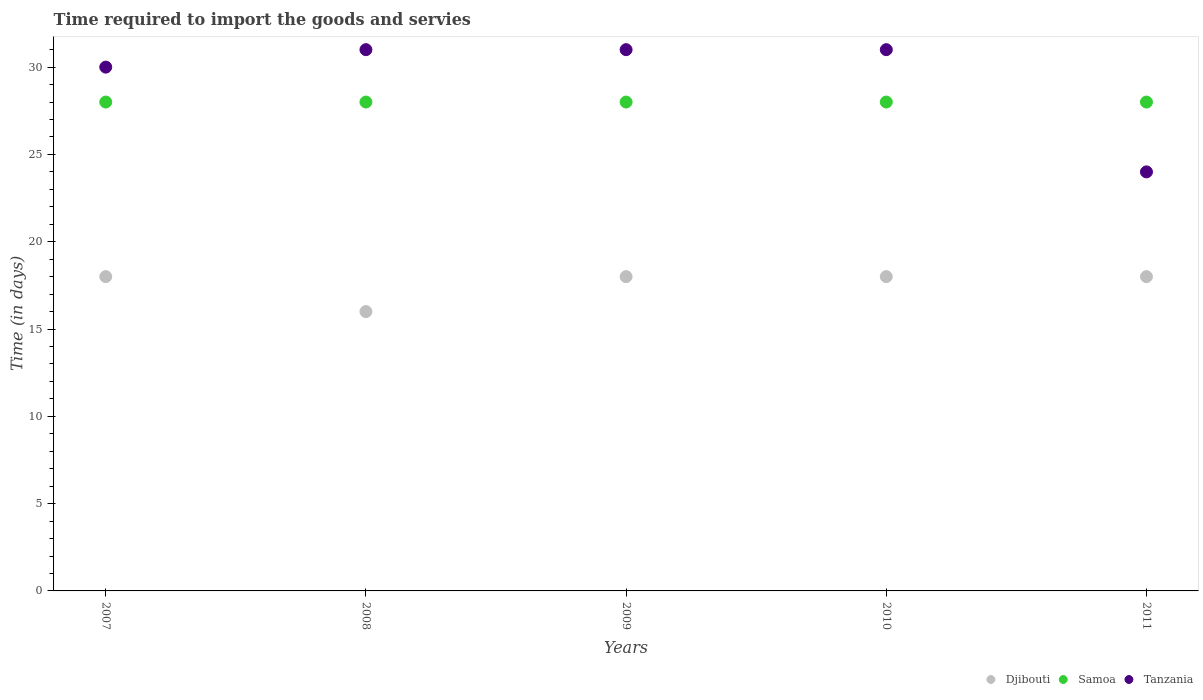What is the number of days required to import the goods and services in Tanzania in 2011?
Your answer should be very brief. 24. Across all years, what is the maximum number of days required to import the goods and services in Samoa?
Give a very brief answer. 28. Across all years, what is the minimum number of days required to import the goods and services in Djibouti?
Make the answer very short. 16. In which year was the number of days required to import the goods and services in Samoa maximum?
Provide a succinct answer. 2007. What is the total number of days required to import the goods and services in Samoa in the graph?
Ensure brevity in your answer.  140. What is the difference between the number of days required to import the goods and services in Djibouti in 2009 and that in 2011?
Make the answer very short. 0. What is the difference between the number of days required to import the goods and services in Djibouti in 2007 and the number of days required to import the goods and services in Samoa in 2010?
Make the answer very short. -10. What is the average number of days required to import the goods and services in Tanzania per year?
Give a very brief answer. 29.4. In the year 2010, what is the difference between the number of days required to import the goods and services in Samoa and number of days required to import the goods and services in Tanzania?
Keep it short and to the point. -3. In how many years, is the number of days required to import the goods and services in Samoa greater than 8 days?
Your answer should be compact. 5. Is the difference between the number of days required to import the goods and services in Samoa in 2010 and 2011 greater than the difference between the number of days required to import the goods and services in Tanzania in 2010 and 2011?
Offer a terse response. No. What is the difference between the highest and the lowest number of days required to import the goods and services in Tanzania?
Make the answer very short. 7. Is the number of days required to import the goods and services in Tanzania strictly greater than the number of days required to import the goods and services in Samoa over the years?
Your response must be concise. No. How many dotlines are there?
Keep it short and to the point. 3. Does the graph contain any zero values?
Your response must be concise. No. Does the graph contain grids?
Your answer should be compact. No. How many legend labels are there?
Your answer should be compact. 3. How are the legend labels stacked?
Your answer should be very brief. Horizontal. What is the title of the graph?
Keep it short and to the point. Time required to import the goods and servies. What is the label or title of the X-axis?
Your response must be concise. Years. What is the label or title of the Y-axis?
Keep it short and to the point. Time (in days). What is the Time (in days) of Djibouti in 2007?
Your answer should be compact. 18. What is the Time (in days) in Djibouti in 2008?
Your answer should be very brief. 16. What is the Time (in days) of Tanzania in 2008?
Provide a succinct answer. 31. What is the Time (in days) of Djibouti in 2009?
Your answer should be compact. 18. What is the Time (in days) in Samoa in 2009?
Ensure brevity in your answer.  28. What is the Time (in days) in Tanzania in 2009?
Provide a short and direct response. 31. What is the Time (in days) in Djibouti in 2010?
Provide a short and direct response. 18. What is the Time (in days) in Tanzania in 2010?
Provide a short and direct response. 31. What is the Time (in days) in Djibouti in 2011?
Provide a short and direct response. 18. What is the Time (in days) of Samoa in 2011?
Ensure brevity in your answer.  28. What is the Time (in days) in Tanzania in 2011?
Provide a succinct answer. 24. Across all years, what is the maximum Time (in days) in Tanzania?
Provide a short and direct response. 31. What is the total Time (in days) in Samoa in the graph?
Make the answer very short. 140. What is the total Time (in days) in Tanzania in the graph?
Give a very brief answer. 147. What is the difference between the Time (in days) of Tanzania in 2007 and that in 2008?
Give a very brief answer. -1. What is the difference between the Time (in days) in Tanzania in 2007 and that in 2009?
Your answer should be compact. -1. What is the difference between the Time (in days) of Tanzania in 2007 and that in 2010?
Ensure brevity in your answer.  -1. What is the difference between the Time (in days) in Djibouti in 2007 and that in 2011?
Your answer should be compact. 0. What is the difference between the Time (in days) of Samoa in 2007 and that in 2011?
Offer a terse response. 0. What is the difference between the Time (in days) of Tanzania in 2007 and that in 2011?
Ensure brevity in your answer.  6. What is the difference between the Time (in days) in Samoa in 2008 and that in 2009?
Your answer should be compact. 0. What is the difference between the Time (in days) in Samoa in 2008 and that in 2010?
Offer a terse response. 0. What is the difference between the Time (in days) of Djibouti in 2008 and that in 2011?
Give a very brief answer. -2. What is the difference between the Time (in days) of Samoa in 2008 and that in 2011?
Give a very brief answer. 0. What is the difference between the Time (in days) in Tanzania in 2008 and that in 2011?
Keep it short and to the point. 7. What is the difference between the Time (in days) of Djibouti in 2009 and that in 2010?
Your answer should be compact. 0. What is the difference between the Time (in days) in Samoa in 2009 and that in 2010?
Provide a succinct answer. 0. What is the difference between the Time (in days) in Djibouti in 2009 and that in 2011?
Your response must be concise. 0. What is the difference between the Time (in days) of Samoa in 2009 and that in 2011?
Your answer should be compact. 0. What is the difference between the Time (in days) of Samoa in 2007 and the Time (in days) of Tanzania in 2009?
Ensure brevity in your answer.  -3. What is the difference between the Time (in days) of Djibouti in 2007 and the Time (in days) of Samoa in 2010?
Provide a short and direct response. -10. What is the difference between the Time (in days) of Djibouti in 2007 and the Time (in days) of Tanzania in 2010?
Make the answer very short. -13. What is the difference between the Time (in days) of Djibouti in 2007 and the Time (in days) of Tanzania in 2011?
Offer a terse response. -6. What is the difference between the Time (in days) in Djibouti in 2008 and the Time (in days) in Samoa in 2009?
Give a very brief answer. -12. What is the difference between the Time (in days) of Djibouti in 2008 and the Time (in days) of Tanzania in 2010?
Your response must be concise. -15. What is the difference between the Time (in days) of Samoa in 2008 and the Time (in days) of Tanzania in 2010?
Provide a short and direct response. -3. What is the difference between the Time (in days) of Djibouti in 2008 and the Time (in days) of Samoa in 2011?
Make the answer very short. -12. What is the difference between the Time (in days) in Samoa in 2008 and the Time (in days) in Tanzania in 2011?
Provide a short and direct response. 4. What is the difference between the Time (in days) of Djibouti in 2009 and the Time (in days) of Samoa in 2010?
Provide a succinct answer. -10. What is the difference between the Time (in days) of Samoa in 2009 and the Time (in days) of Tanzania in 2010?
Your answer should be very brief. -3. What is the difference between the Time (in days) of Djibouti in 2009 and the Time (in days) of Samoa in 2011?
Your answer should be compact. -10. What is the difference between the Time (in days) of Samoa in 2009 and the Time (in days) of Tanzania in 2011?
Offer a very short reply. 4. What is the difference between the Time (in days) in Samoa in 2010 and the Time (in days) in Tanzania in 2011?
Provide a short and direct response. 4. What is the average Time (in days) of Djibouti per year?
Provide a succinct answer. 17.6. What is the average Time (in days) of Samoa per year?
Your response must be concise. 28. What is the average Time (in days) of Tanzania per year?
Provide a short and direct response. 29.4. In the year 2008, what is the difference between the Time (in days) in Djibouti and Time (in days) in Tanzania?
Give a very brief answer. -15. In the year 2009, what is the difference between the Time (in days) in Djibouti and Time (in days) in Samoa?
Provide a short and direct response. -10. In the year 2009, what is the difference between the Time (in days) of Djibouti and Time (in days) of Tanzania?
Your response must be concise. -13. In the year 2009, what is the difference between the Time (in days) of Samoa and Time (in days) of Tanzania?
Give a very brief answer. -3. In the year 2010, what is the difference between the Time (in days) of Samoa and Time (in days) of Tanzania?
Offer a very short reply. -3. In the year 2011, what is the difference between the Time (in days) in Djibouti and Time (in days) in Tanzania?
Provide a succinct answer. -6. What is the ratio of the Time (in days) of Djibouti in 2007 to that in 2008?
Offer a terse response. 1.12. What is the ratio of the Time (in days) of Tanzania in 2007 to that in 2009?
Provide a short and direct response. 0.97. What is the ratio of the Time (in days) of Djibouti in 2007 to that in 2010?
Your response must be concise. 1. What is the ratio of the Time (in days) of Samoa in 2007 to that in 2011?
Keep it short and to the point. 1. What is the ratio of the Time (in days) in Samoa in 2008 to that in 2009?
Your response must be concise. 1. What is the ratio of the Time (in days) in Samoa in 2008 to that in 2010?
Keep it short and to the point. 1. What is the ratio of the Time (in days) in Tanzania in 2008 to that in 2010?
Offer a very short reply. 1. What is the ratio of the Time (in days) of Djibouti in 2008 to that in 2011?
Provide a succinct answer. 0.89. What is the ratio of the Time (in days) in Samoa in 2008 to that in 2011?
Offer a terse response. 1. What is the ratio of the Time (in days) of Tanzania in 2008 to that in 2011?
Ensure brevity in your answer.  1.29. What is the ratio of the Time (in days) in Djibouti in 2009 to that in 2010?
Ensure brevity in your answer.  1. What is the ratio of the Time (in days) of Samoa in 2009 to that in 2010?
Make the answer very short. 1. What is the ratio of the Time (in days) of Tanzania in 2009 to that in 2010?
Offer a very short reply. 1. What is the ratio of the Time (in days) of Djibouti in 2009 to that in 2011?
Your answer should be compact. 1. What is the ratio of the Time (in days) of Samoa in 2009 to that in 2011?
Offer a very short reply. 1. What is the ratio of the Time (in days) in Tanzania in 2009 to that in 2011?
Give a very brief answer. 1.29. What is the ratio of the Time (in days) in Samoa in 2010 to that in 2011?
Provide a succinct answer. 1. What is the ratio of the Time (in days) in Tanzania in 2010 to that in 2011?
Your answer should be very brief. 1.29. What is the difference between the highest and the second highest Time (in days) of Djibouti?
Provide a succinct answer. 0. What is the difference between the highest and the second highest Time (in days) in Samoa?
Keep it short and to the point. 0. What is the difference between the highest and the second highest Time (in days) of Tanzania?
Ensure brevity in your answer.  0. 